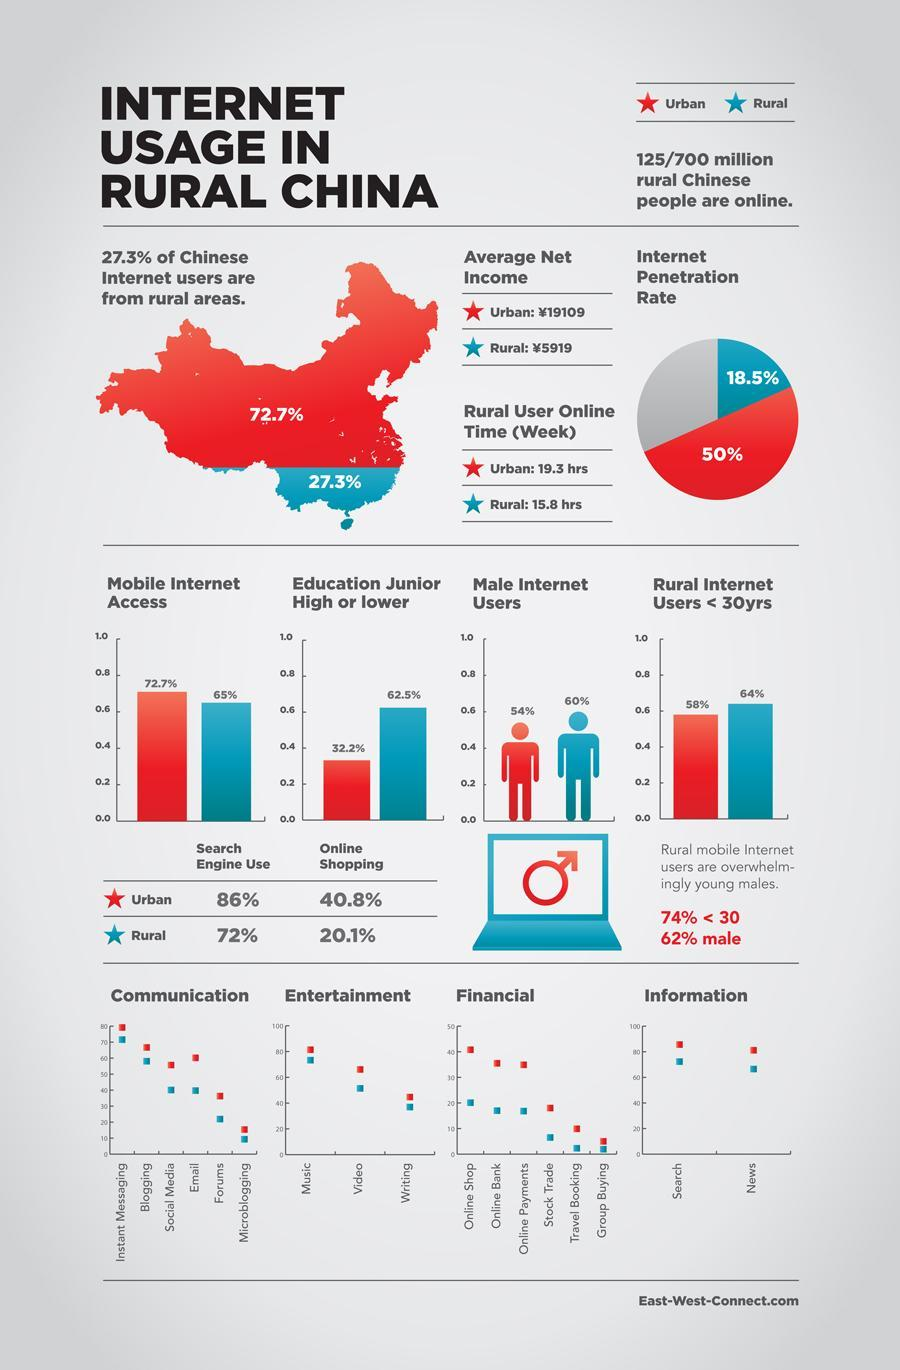Among male internet users, males from which region uses internet more- rural or urban?
Answer the question with a short phrase. Urban Which user spend most time online- rural or urban? Urban In which area is online shopping rate lesser? Rural What is the internet penetration rate in rural China? 18.5% What percent of internet users in China are from urban areas? 72.7% 